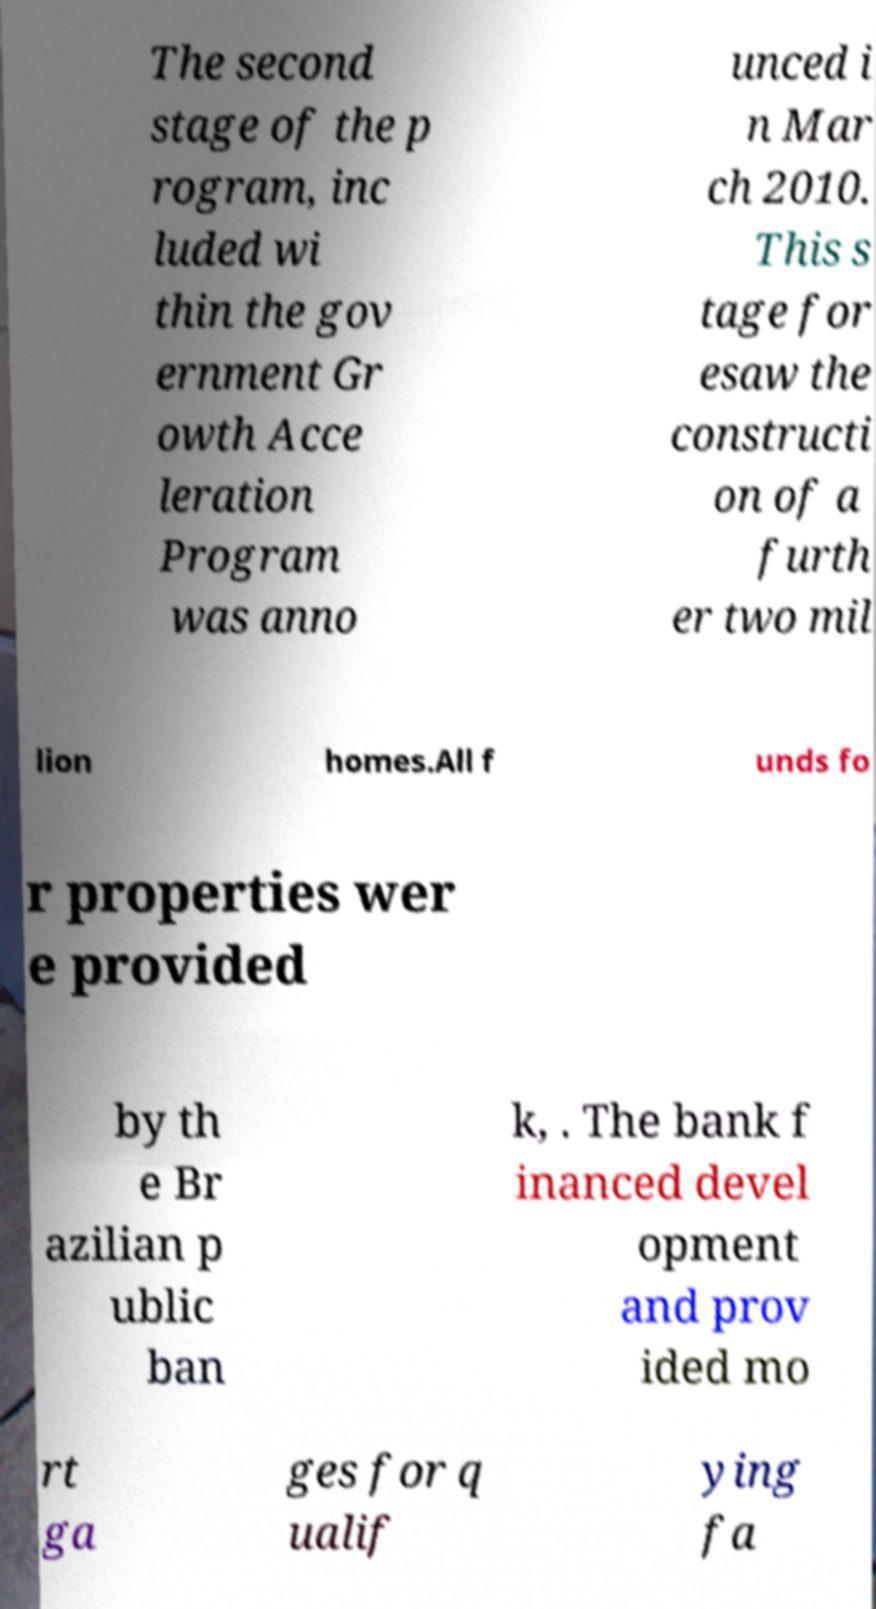Could you assist in decoding the text presented in this image and type it out clearly? The second stage of the p rogram, inc luded wi thin the gov ernment Gr owth Acce leration Program was anno unced i n Mar ch 2010. This s tage for esaw the constructi on of a furth er two mil lion homes.All f unds fo r properties wer e provided by th e Br azilian p ublic ban k, . The bank f inanced devel opment and prov ided mo rt ga ges for q ualif ying fa 